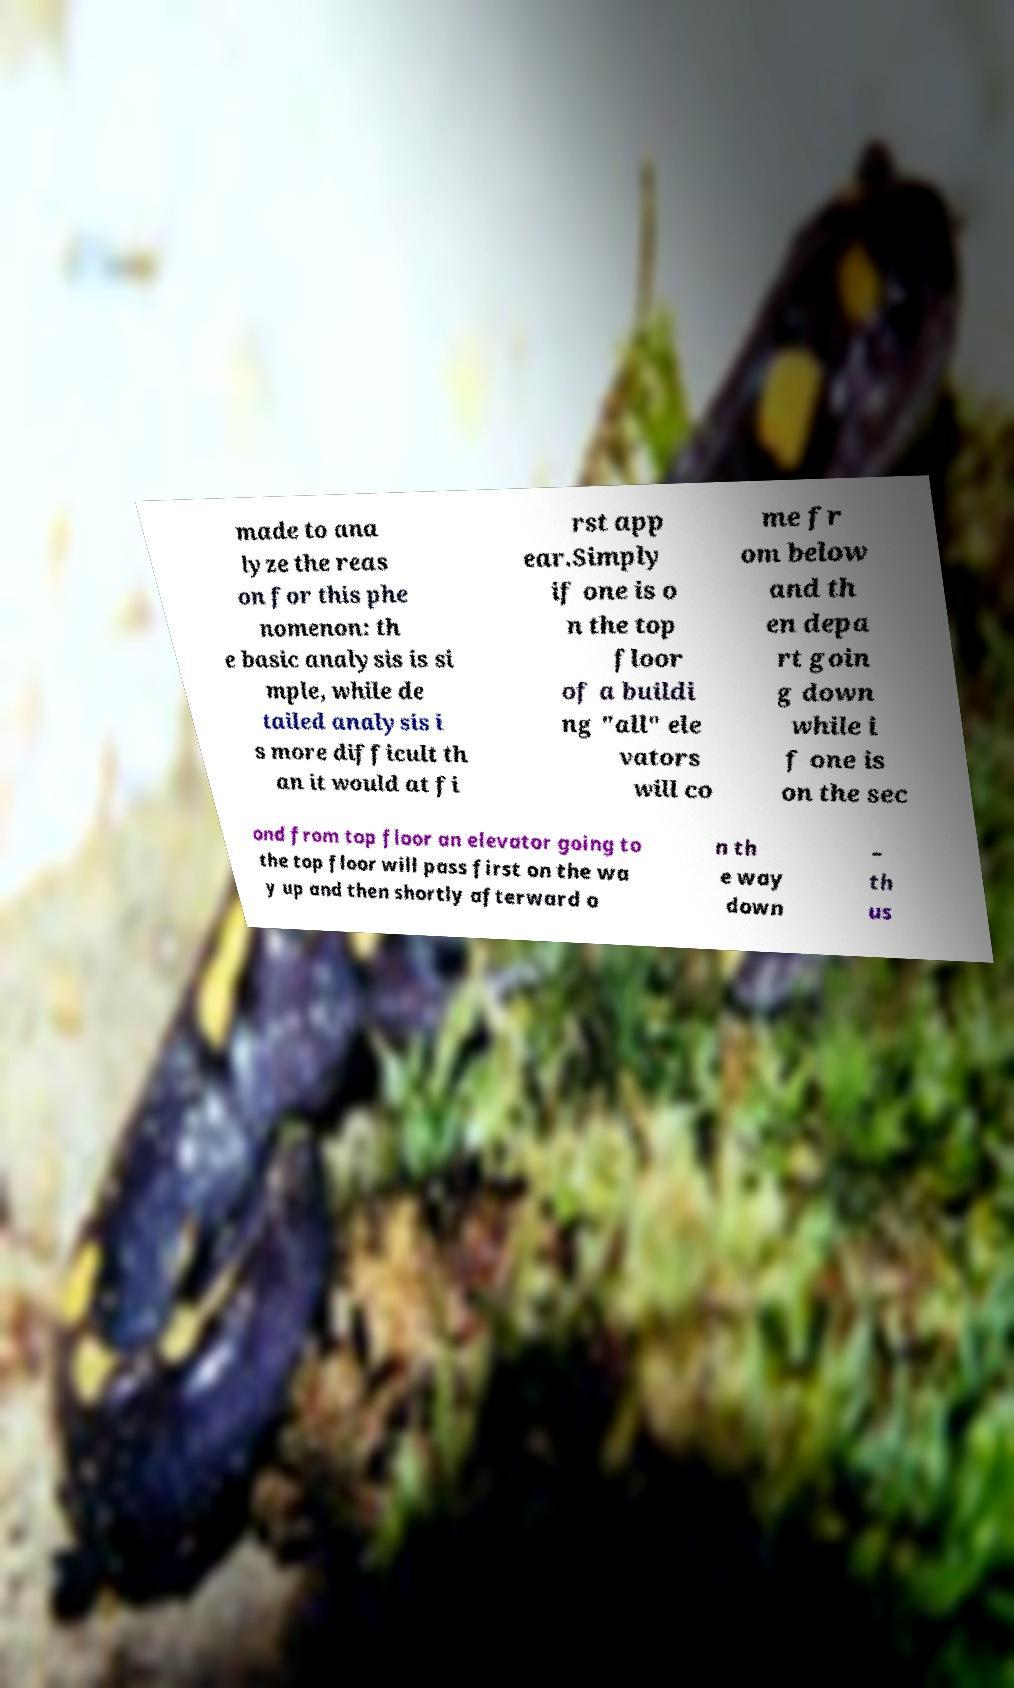Can you accurately transcribe the text from the provided image for me? made to ana lyze the reas on for this phe nomenon: th e basic analysis is si mple, while de tailed analysis i s more difficult th an it would at fi rst app ear.Simply if one is o n the top floor of a buildi ng "all" ele vators will co me fr om below and th en depa rt goin g down while i f one is on the sec ond from top floor an elevator going to the top floor will pass first on the wa y up and then shortly afterward o n th e way down – th us 